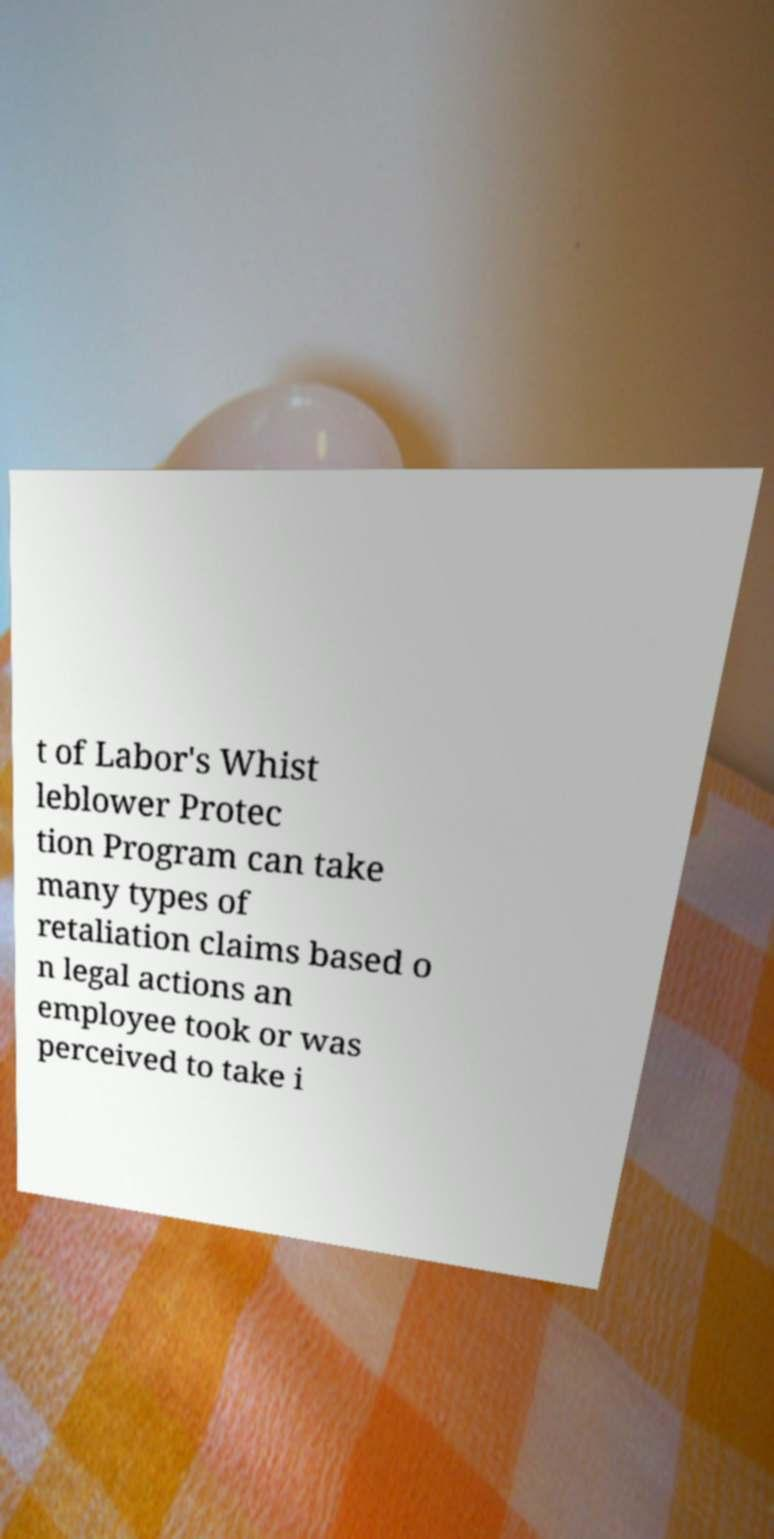There's text embedded in this image that I need extracted. Can you transcribe it verbatim? t of Labor's Whist leblower Protec tion Program can take many types of retaliation claims based o n legal actions an employee took or was perceived to take i 